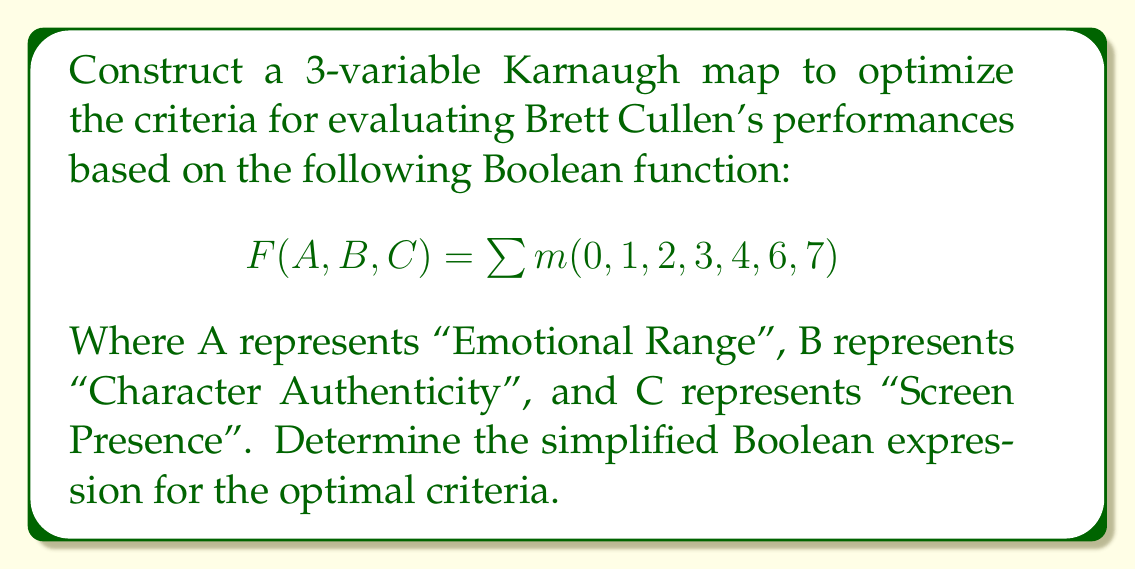What is the answer to this math problem? 1. First, let's create the 3-variable Karnaugh map:

[asy]
unitsize(1cm);

draw((0,0)--(4,0)--(4,2)--(0,2)--cycle);
draw((1,0)--(1,2));
draw((2,0)--(2,2));
draw((3,0)--(3,2));
draw((0,1)--(4,1));

label("00", (0.5,2.5));
label("01", (1.5,2.5));
label("11", (2.5,2.5));
label("10", (3.5,2.5));

label("0", (-0.5,1.5));
label("1", (-0.5,0.5));

label("1", (0.5,1.5));
label("1", (1.5,1.5));
label("0", (2.5,1.5));
label("1", (3.5,1.5));

label("1", (0.5,0.5));
label("1", (1.5,0.5));
label("1", (2.5,0.5));
label("1", (3.5,0.5));

label("AB", (-0.5,2.5));
label("C", (-1,1));
[/asy]

2. Identify the largest possible groups of 1's:
   - One group of 4: $\overline{A}$ (top row)
   - One group of 4: $C$ (bottom row)

3. The simplified Boolean expression is the OR of these groups:

   $$F(A,B,C) = \overline{A} + C$$

4. Interpret the result:
   - Cullen's performance is considered optimal when either:
     a) He doesn't demonstrate a wide emotional range (perhaps focusing on a specific emotion), OR
     b) He has a strong screen presence

This simplified criteria suggests that for Brett Cullen's performances, critics should focus on either his ability to convey specific emotions effectively or his overall screen presence, rather than requiring both simultaneously.
Answer: $$F(A,B,C) = \overline{A} + C$$ 